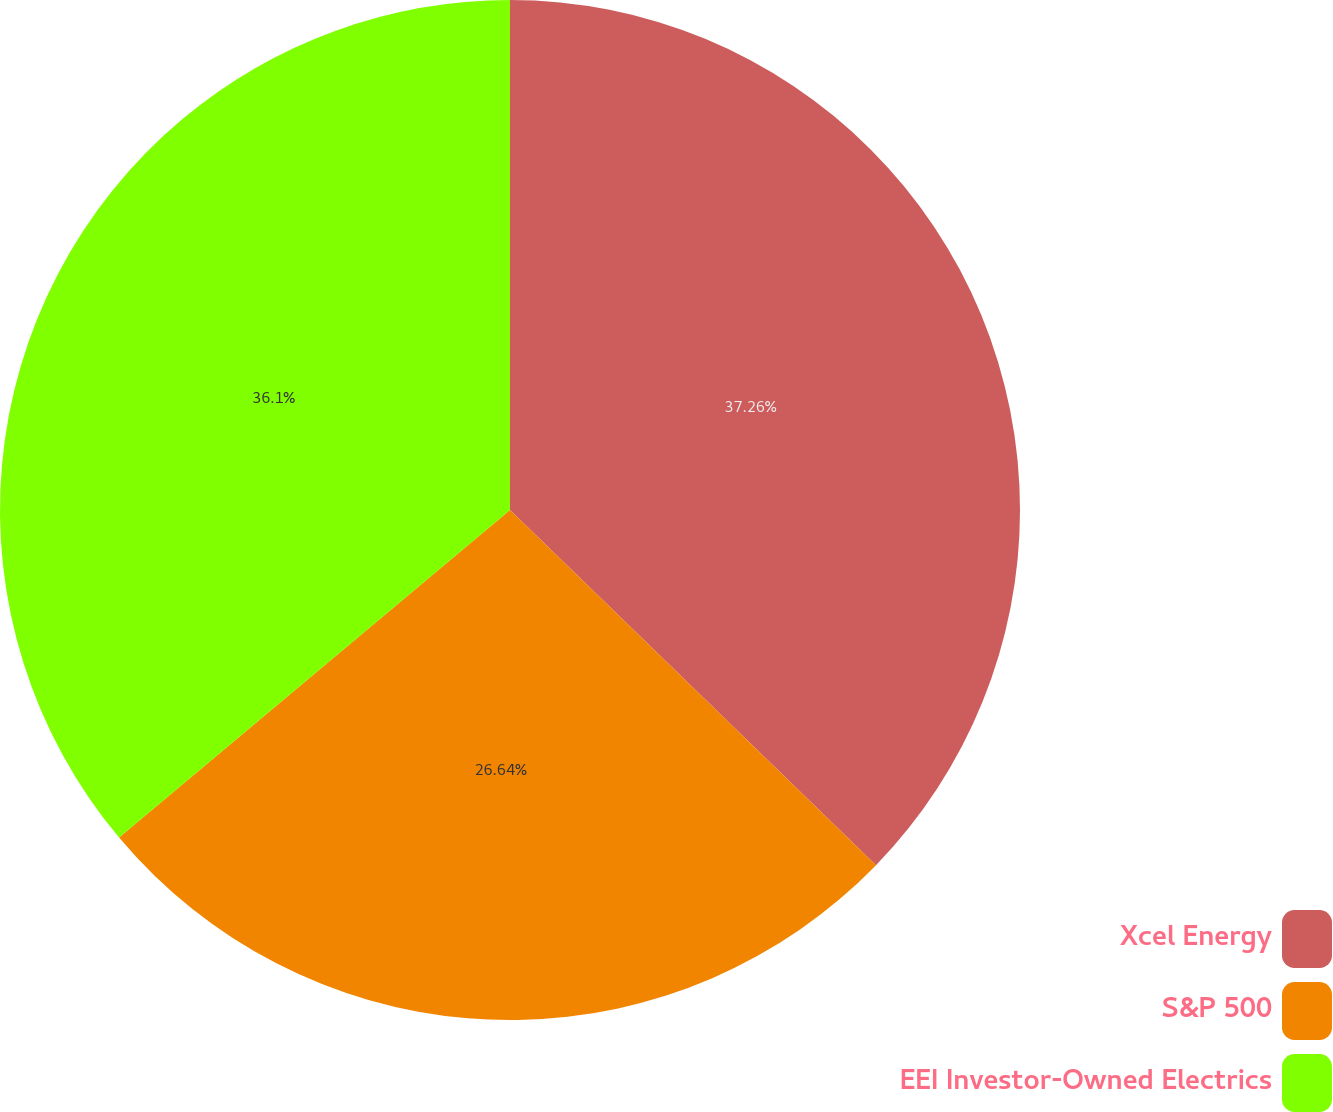Convert chart to OTSL. <chart><loc_0><loc_0><loc_500><loc_500><pie_chart><fcel>Xcel Energy<fcel>S&P 500<fcel>EEI Investor-Owned Electrics<nl><fcel>37.26%<fcel>26.64%<fcel>36.1%<nl></chart> 